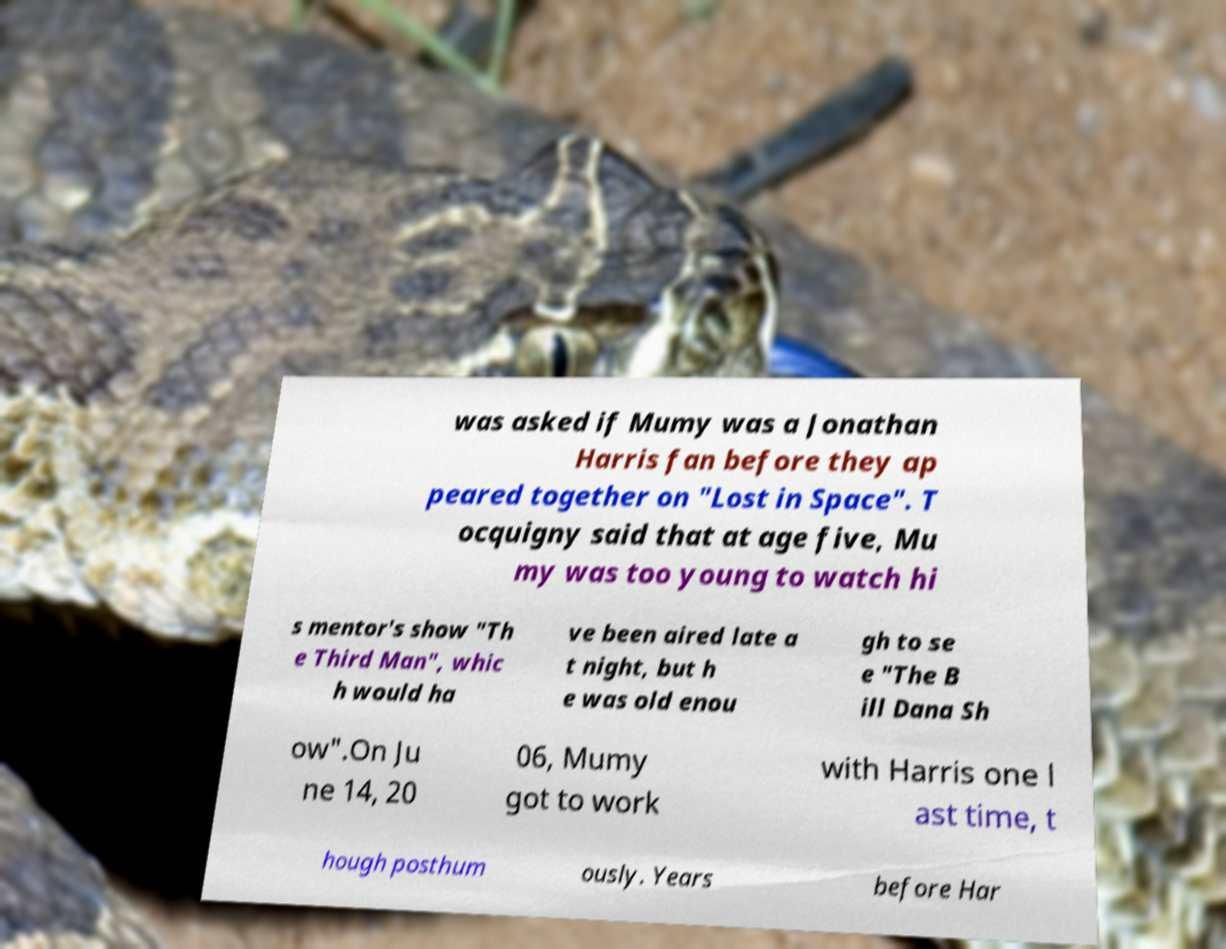Please read and relay the text visible in this image. What does it say? was asked if Mumy was a Jonathan Harris fan before they ap peared together on "Lost in Space". T ocquigny said that at age five, Mu my was too young to watch hi s mentor's show "Th e Third Man", whic h would ha ve been aired late a t night, but h e was old enou gh to se e "The B ill Dana Sh ow".On Ju ne 14, 20 06, Mumy got to work with Harris one l ast time, t hough posthum ously. Years before Har 